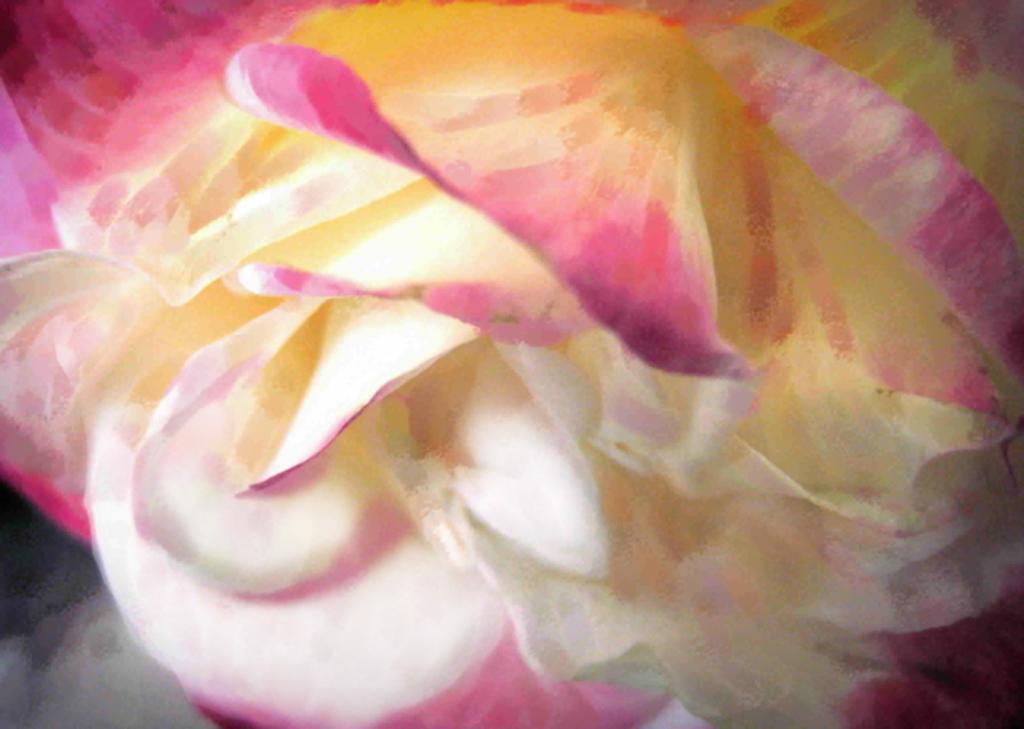In one or two sentences, can you explain what this image depicts? This image is a painting. In this painting we can see a flower. 